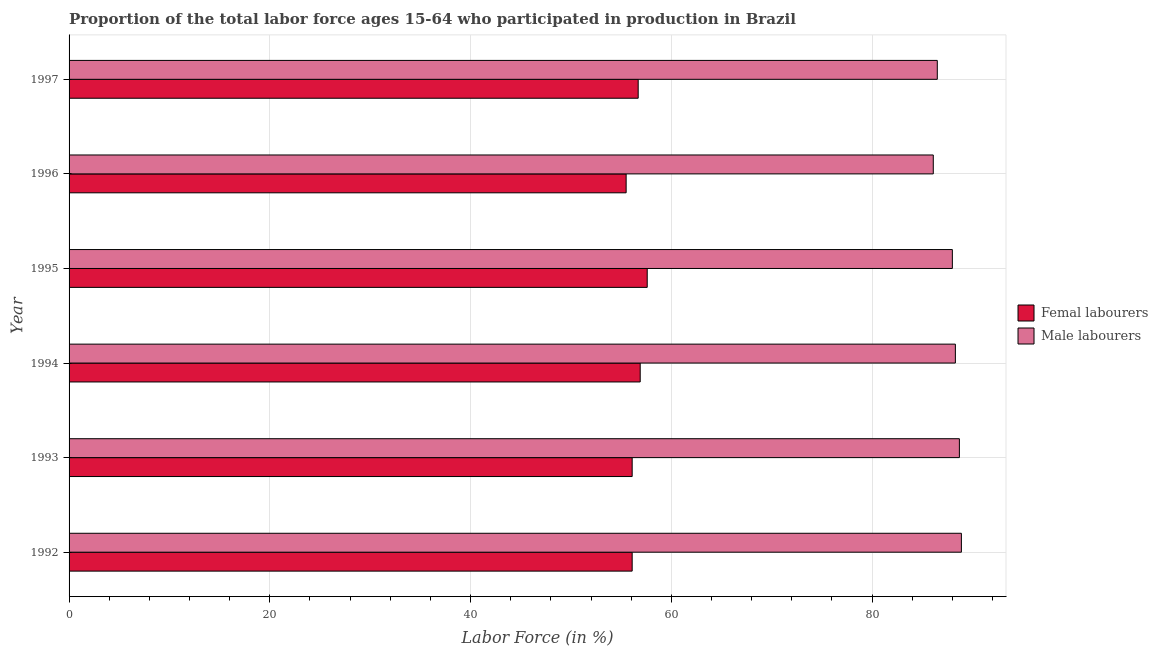How many bars are there on the 6th tick from the bottom?
Provide a succinct answer. 2. In how many cases, is the number of bars for a given year not equal to the number of legend labels?
Ensure brevity in your answer.  0. What is the percentage of male labour force in 1996?
Make the answer very short. 86.1. Across all years, what is the maximum percentage of male labour force?
Offer a very short reply. 88.9. Across all years, what is the minimum percentage of male labour force?
Provide a succinct answer. 86.1. What is the total percentage of female labor force in the graph?
Your answer should be very brief. 338.9. What is the difference between the percentage of male labour force in 1992 and that in 1997?
Offer a terse response. 2.4. What is the difference between the percentage of female labor force in 1994 and the percentage of male labour force in 1997?
Offer a terse response. -29.6. What is the average percentage of female labor force per year?
Your response must be concise. 56.48. In the year 1995, what is the difference between the percentage of female labor force and percentage of male labour force?
Your response must be concise. -30.4. Is the percentage of female labor force in 1994 less than that in 1996?
Keep it short and to the point. No. What is the difference between the highest and the second highest percentage of male labour force?
Offer a very short reply. 0.2. In how many years, is the percentage of female labor force greater than the average percentage of female labor force taken over all years?
Your response must be concise. 3. What does the 1st bar from the top in 1992 represents?
Your response must be concise. Male labourers. What does the 1st bar from the bottom in 1995 represents?
Your answer should be compact. Femal labourers. How many bars are there?
Keep it short and to the point. 12. What is the difference between two consecutive major ticks on the X-axis?
Offer a terse response. 20. Are the values on the major ticks of X-axis written in scientific E-notation?
Your response must be concise. No. Does the graph contain grids?
Your answer should be compact. Yes. What is the title of the graph?
Offer a very short reply. Proportion of the total labor force ages 15-64 who participated in production in Brazil. Does "External balance on goods" appear as one of the legend labels in the graph?
Your response must be concise. No. What is the label or title of the Y-axis?
Your response must be concise. Year. What is the Labor Force (in %) of Femal labourers in 1992?
Keep it short and to the point. 56.1. What is the Labor Force (in %) of Male labourers in 1992?
Offer a very short reply. 88.9. What is the Labor Force (in %) of Femal labourers in 1993?
Give a very brief answer. 56.1. What is the Labor Force (in %) of Male labourers in 1993?
Keep it short and to the point. 88.7. What is the Labor Force (in %) of Femal labourers in 1994?
Keep it short and to the point. 56.9. What is the Labor Force (in %) of Male labourers in 1994?
Your response must be concise. 88.3. What is the Labor Force (in %) in Femal labourers in 1995?
Ensure brevity in your answer.  57.6. What is the Labor Force (in %) of Male labourers in 1995?
Ensure brevity in your answer.  88. What is the Labor Force (in %) in Femal labourers in 1996?
Make the answer very short. 55.5. What is the Labor Force (in %) in Male labourers in 1996?
Offer a terse response. 86.1. What is the Labor Force (in %) of Femal labourers in 1997?
Your answer should be very brief. 56.7. What is the Labor Force (in %) in Male labourers in 1997?
Keep it short and to the point. 86.5. Across all years, what is the maximum Labor Force (in %) in Femal labourers?
Your answer should be very brief. 57.6. Across all years, what is the maximum Labor Force (in %) in Male labourers?
Your answer should be very brief. 88.9. Across all years, what is the minimum Labor Force (in %) of Femal labourers?
Offer a very short reply. 55.5. Across all years, what is the minimum Labor Force (in %) of Male labourers?
Your answer should be very brief. 86.1. What is the total Labor Force (in %) of Femal labourers in the graph?
Make the answer very short. 338.9. What is the total Labor Force (in %) of Male labourers in the graph?
Provide a succinct answer. 526.5. What is the difference between the Labor Force (in %) of Femal labourers in 1992 and that in 1993?
Provide a succinct answer. 0. What is the difference between the Labor Force (in %) in Femal labourers in 1992 and that in 1994?
Make the answer very short. -0.8. What is the difference between the Labor Force (in %) of Femal labourers in 1992 and that in 1996?
Your answer should be compact. 0.6. What is the difference between the Labor Force (in %) of Male labourers in 1992 and that in 1996?
Give a very brief answer. 2.8. What is the difference between the Labor Force (in %) in Male labourers in 1992 and that in 1997?
Keep it short and to the point. 2.4. What is the difference between the Labor Force (in %) of Male labourers in 1993 and that in 1994?
Give a very brief answer. 0.4. What is the difference between the Labor Force (in %) of Femal labourers in 1993 and that in 1995?
Give a very brief answer. -1.5. What is the difference between the Labor Force (in %) in Male labourers in 1993 and that in 1995?
Make the answer very short. 0.7. What is the difference between the Labor Force (in %) of Femal labourers in 1993 and that in 1996?
Your answer should be very brief. 0.6. What is the difference between the Labor Force (in %) in Male labourers in 1993 and that in 1997?
Provide a short and direct response. 2.2. What is the difference between the Labor Force (in %) of Male labourers in 1994 and that in 1995?
Provide a short and direct response. 0.3. What is the difference between the Labor Force (in %) of Femal labourers in 1995 and that in 1996?
Your answer should be compact. 2.1. What is the difference between the Labor Force (in %) of Male labourers in 1995 and that in 1996?
Make the answer very short. 1.9. What is the difference between the Labor Force (in %) in Femal labourers in 1995 and that in 1997?
Your response must be concise. 0.9. What is the difference between the Labor Force (in %) in Femal labourers in 1996 and that in 1997?
Ensure brevity in your answer.  -1.2. What is the difference between the Labor Force (in %) in Femal labourers in 1992 and the Labor Force (in %) in Male labourers in 1993?
Make the answer very short. -32.6. What is the difference between the Labor Force (in %) in Femal labourers in 1992 and the Labor Force (in %) in Male labourers in 1994?
Your answer should be compact. -32.2. What is the difference between the Labor Force (in %) of Femal labourers in 1992 and the Labor Force (in %) of Male labourers in 1995?
Provide a succinct answer. -31.9. What is the difference between the Labor Force (in %) of Femal labourers in 1992 and the Labor Force (in %) of Male labourers in 1996?
Your response must be concise. -30. What is the difference between the Labor Force (in %) in Femal labourers in 1992 and the Labor Force (in %) in Male labourers in 1997?
Offer a terse response. -30.4. What is the difference between the Labor Force (in %) in Femal labourers in 1993 and the Labor Force (in %) in Male labourers in 1994?
Your answer should be very brief. -32.2. What is the difference between the Labor Force (in %) in Femal labourers in 1993 and the Labor Force (in %) in Male labourers in 1995?
Make the answer very short. -31.9. What is the difference between the Labor Force (in %) in Femal labourers in 1993 and the Labor Force (in %) in Male labourers in 1997?
Your response must be concise. -30.4. What is the difference between the Labor Force (in %) of Femal labourers in 1994 and the Labor Force (in %) of Male labourers in 1995?
Ensure brevity in your answer.  -31.1. What is the difference between the Labor Force (in %) in Femal labourers in 1994 and the Labor Force (in %) in Male labourers in 1996?
Provide a short and direct response. -29.2. What is the difference between the Labor Force (in %) in Femal labourers in 1994 and the Labor Force (in %) in Male labourers in 1997?
Provide a short and direct response. -29.6. What is the difference between the Labor Force (in %) in Femal labourers in 1995 and the Labor Force (in %) in Male labourers in 1996?
Give a very brief answer. -28.5. What is the difference between the Labor Force (in %) in Femal labourers in 1995 and the Labor Force (in %) in Male labourers in 1997?
Provide a succinct answer. -28.9. What is the difference between the Labor Force (in %) of Femal labourers in 1996 and the Labor Force (in %) of Male labourers in 1997?
Keep it short and to the point. -31. What is the average Labor Force (in %) of Femal labourers per year?
Keep it short and to the point. 56.48. What is the average Labor Force (in %) of Male labourers per year?
Provide a short and direct response. 87.75. In the year 1992, what is the difference between the Labor Force (in %) of Femal labourers and Labor Force (in %) of Male labourers?
Your response must be concise. -32.8. In the year 1993, what is the difference between the Labor Force (in %) of Femal labourers and Labor Force (in %) of Male labourers?
Your response must be concise. -32.6. In the year 1994, what is the difference between the Labor Force (in %) of Femal labourers and Labor Force (in %) of Male labourers?
Give a very brief answer. -31.4. In the year 1995, what is the difference between the Labor Force (in %) of Femal labourers and Labor Force (in %) of Male labourers?
Your answer should be compact. -30.4. In the year 1996, what is the difference between the Labor Force (in %) of Femal labourers and Labor Force (in %) of Male labourers?
Ensure brevity in your answer.  -30.6. In the year 1997, what is the difference between the Labor Force (in %) in Femal labourers and Labor Force (in %) in Male labourers?
Provide a succinct answer. -29.8. What is the ratio of the Labor Force (in %) in Male labourers in 1992 to that in 1993?
Give a very brief answer. 1. What is the ratio of the Labor Force (in %) of Femal labourers in 1992 to that in 1994?
Make the answer very short. 0.99. What is the ratio of the Labor Force (in %) of Male labourers in 1992 to that in 1994?
Offer a very short reply. 1.01. What is the ratio of the Labor Force (in %) of Femal labourers in 1992 to that in 1995?
Provide a succinct answer. 0.97. What is the ratio of the Labor Force (in %) of Male labourers in 1992 to that in 1995?
Provide a succinct answer. 1.01. What is the ratio of the Labor Force (in %) in Femal labourers in 1992 to that in 1996?
Provide a succinct answer. 1.01. What is the ratio of the Labor Force (in %) of Male labourers in 1992 to that in 1996?
Your answer should be very brief. 1.03. What is the ratio of the Labor Force (in %) of Male labourers in 1992 to that in 1997?
Offer a terse response. 1.03. What is the ratio of the Labor Force (in %) of Femal labourers in 1993 to that in 1994?
Offer a very short reply. 0.99. What is the ratio of the Labor Force (in %) in Male labourers in 1993 to that in 1994?
Provide a short and direct response. 1. What is the ratio of the Labor Force (in %) in Femal labourers in 1993 to that in 1995?
Ensure brevity in your answer.  0.97. What is the ratio of the Labor Force (in %) of Male labourers in 1993 to that in 1995?
Make the answer very short. 1.01. What is the ratio of the Labor Force (in %) in Femal labourers in 1993 to that in 1996?
Keep it short and to the point. 1.01. What is the ratio of the Labor Force (in %) in Male labourers in 1993 to that in 1996?
Give a very brief answer. 1.03. What is the ratio of the Labor Force (in %) in Male labourers in 1993 to that in 1997?
Provide a short and direct response. 1.03. What is the ratio of the Labor Force (in %) of Femal labourers in 1994 to that in 1995?
Provide a succinct answer. 0.99. What is the ratio of the Labor Force (in %) of Male labourers in 1994 to that in 1995?
Provide a succinct answer. 1. What is the ratio of the Labor Force (in %) of Femal labourers in 1994 to that in 1996?
Keep it short and to the point. 1.03. What is the ratio of the Labor Force (in %) of Male labourers in 1994 to that in 1996?
Your answer should be compact. 1.03. What is the ratio of the Labor Force (in %) in Male labourers in 1994 to that in 1997?
Provide a succinct answer. 1.02. What is the ratio of the Labor Force (in %) in Femal labourers in 1995 to that in 1996?
Give a very brief answer. 1.04. What is the ratio of the Labor Force (in %) of Male labourers in 1995 to that in 1996?
Your answer should be very brief. 1.02. What is the ratio of the Labor Force (in %) of Femal labourers in 1995 to that in 1997?
Keep it short and to the point. 1.02. What is the ratio of the Labor Force (in %) in Male labourers in 1995 to that in 1997?
Offer a very short reply. 1.02. What is the ratio of the Labor Force (in %) in Femal labourers in 1996 to that in 1997?
Offer a very short reply. 0.98. What is the ratio of the Labor Force (in %) of Male labourers in 1996 to that in 1997?
Provide a short and direct response. 1. 